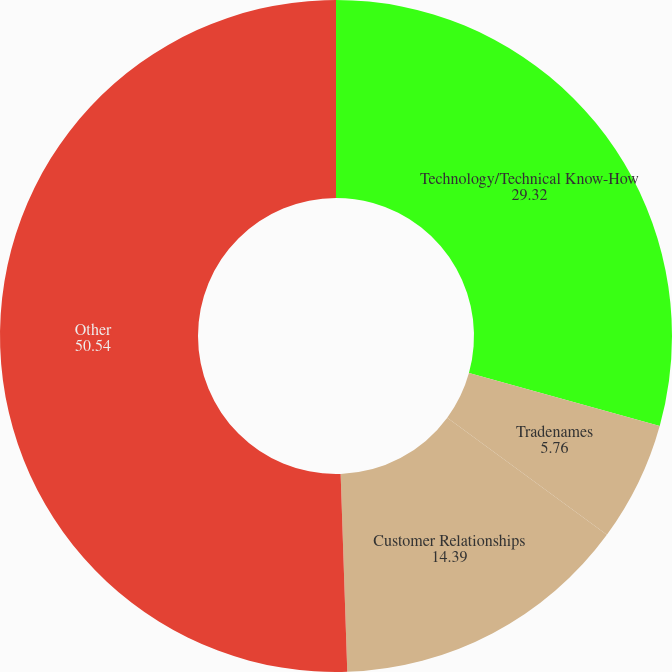<chart> <loc_0><loc_0><loc_500><loc_500><pie_chart><fcel>Technology/Technical Know-How<fcel>Tradenames<fcel>Customer Relationships<fcel>Other<nl><fcel>29.32%<fcel>5.76%<fcel>14.39%<fcel>50.54%<nl></chart> 